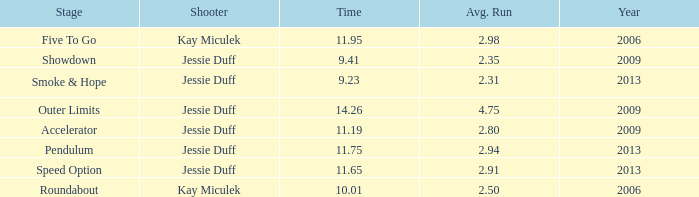How many total years have an average of less than 4.75 runs and a 14.26 time? 0.0. 